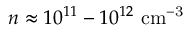<formula> <loc_0><loc_0><loc_500><loc_500>n \approx 1 0 ^ { 1 1 } - 1 0 ^ { 1 2 } c m ^ { - 3 }</formula> 